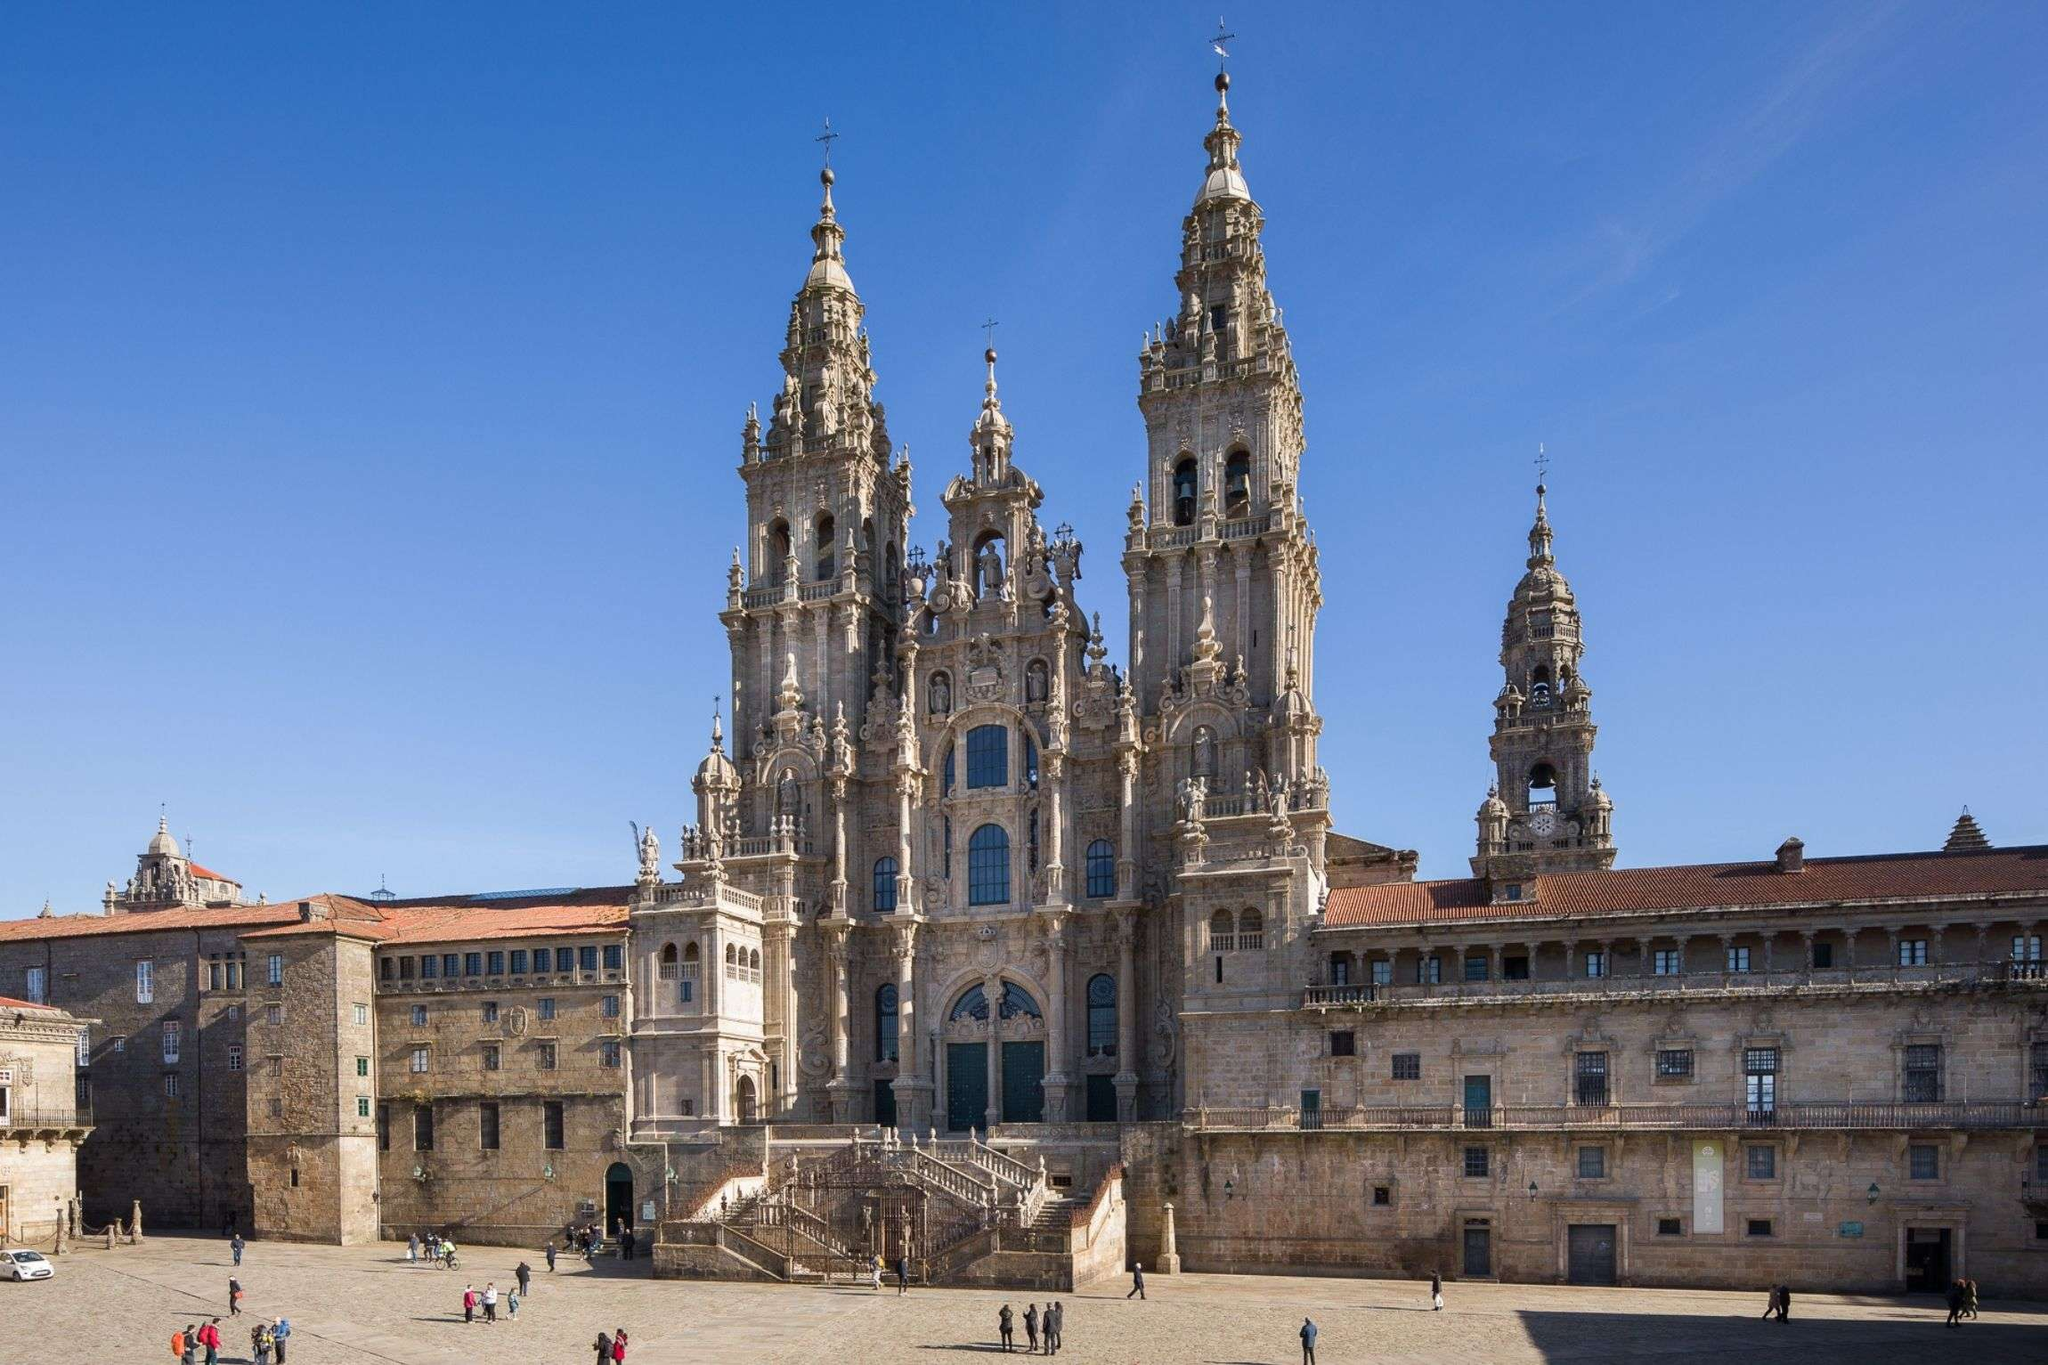How does this image reflect the historical significance of the Cathedral Santiago De Compostela? This image of the Cathedral Santiago De Compostela not only showcases its architectural splendor but also hints at its historical significance as the destination for millions of pilgrims participating in the Camino de Santiago. The grandeur of the cathedral, with its elaborate facades and towering spires, serves as a symbol of the spiritual journey and devotion demonstrated by pilgrims over centuries. Its placement at the heart of a large plaza also points to its role as a central meeting place and a hub of Christian faith in medieval Europe, continuing to this day. 